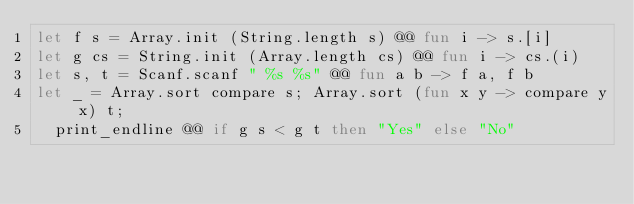Convert code to text. <code><loc_0><loc_0><loc_500><loc_500><_OCaml_>let f s = Array.init (String.length s) @@ fun i -> s.[i]
let g cs = String.init (Array.length cs) @@ fun i -> cs.(i)
let s, t = Scanf.scanf " %s %s" @@ fun a b -> f a, f b
let _ = Array.sort compare s; Array.sort (fun x y -> compare y x) t;
  print_endline @@ if g s < g t then "Yes" else "No"</code> 